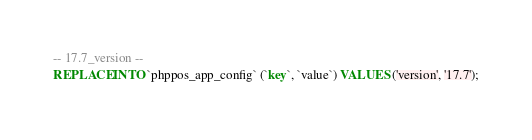<code> <loc_0><loc_0><loc_500><loc_500><_SQL_>-- 17.7_version --
REPLACE INTO `phppos_app_config` (`key`, `value`) VALUES ('version', '17.7');</code> 